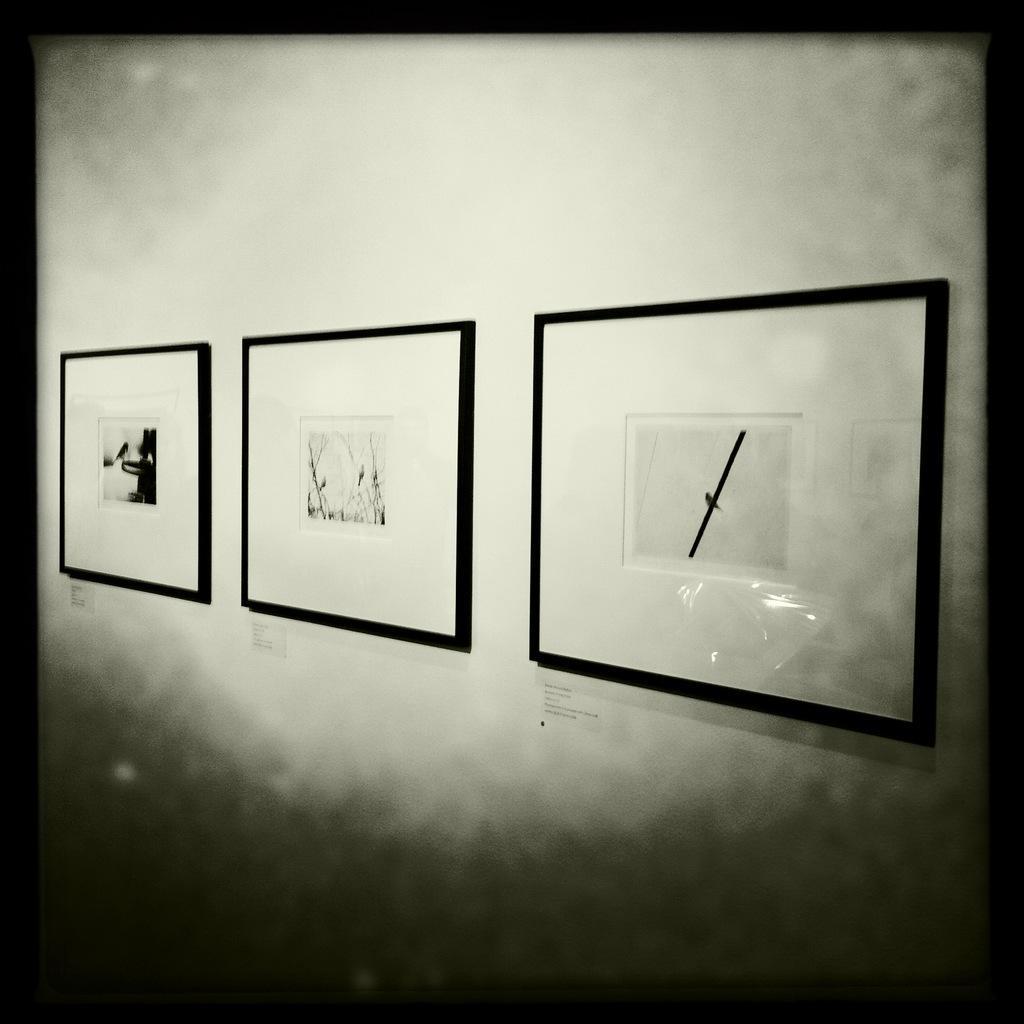Can you describe this image briefly? This image is a black and white image. This image is taken indoors. In this image there is a wall with three picture frames on it. 